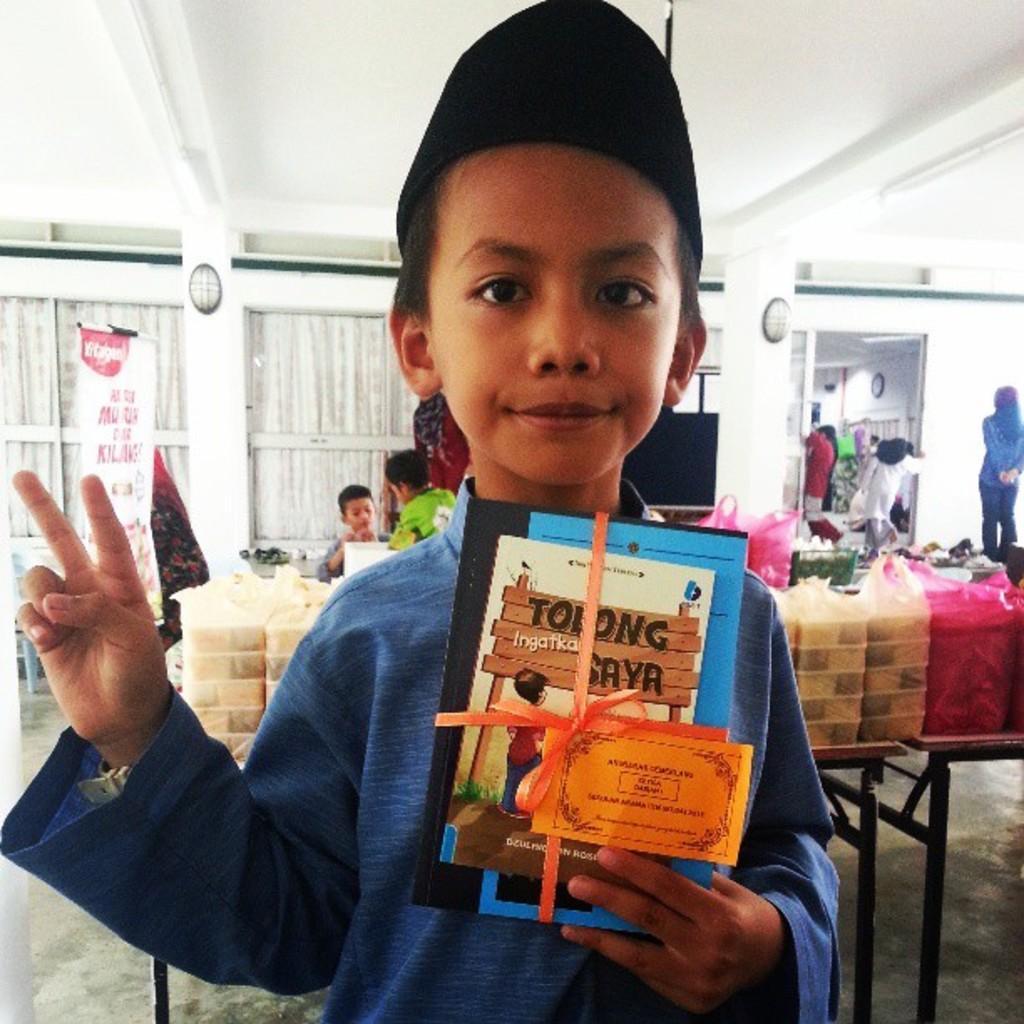Could you give a brief overview of what you see in this image? In this picture we can see a boy holding books with his hand and in the background we can see plastic covers, windows with curtains, banner and some people standing on the floor. 